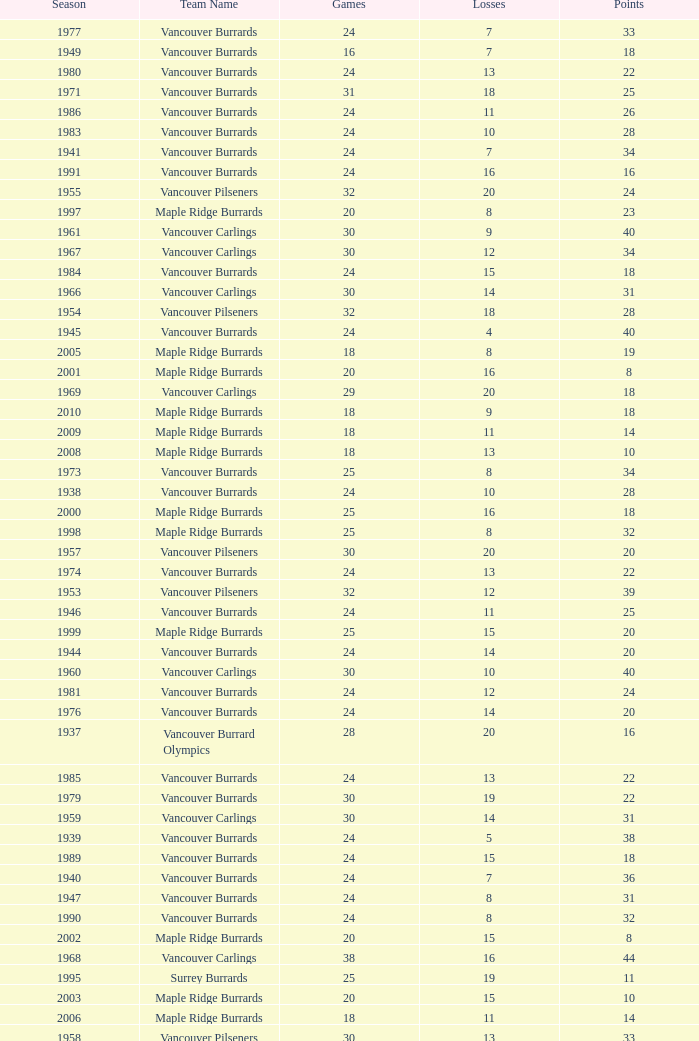What's the total losses for the vancouver burrards in the 1947 season with fewer than 24 games? 0.0. 